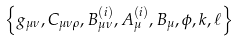<formula> <loc_0><loc_0><loc_500><loc_500>\left \{ g _ { \mu \nu } , C _ { \mu \nu \rho } , B ^ { ( i ) } _ { \mu \nu } , A ^ { ( i ) } _ { \mu } , B _ { \mu } , \phi , k , \ell \right \}</formula> 